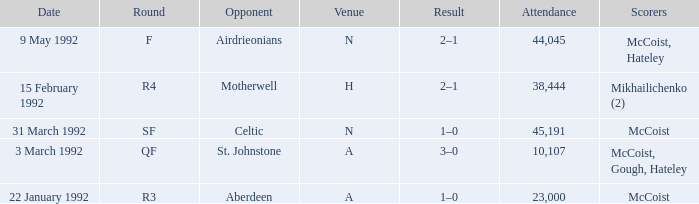Could you parse the entire table? {'header': ['Date', 'Round', 'Opponent', 'Venue', 'Result', 'Attendance', 'Scorers'], 'rows': [['9 May 1992', 'F', 'Airdrieonians', 'N', '2–1', '44,045', 'McCoist, Hateley'], ['15 February 1992', 'R4', 'Motherwell', 'H', '2–1', '38,444', 'Mikhailichenko (2)'], ['31 March 1992', 'SF', 'Celtic', 'N', '1–0', '45,191', 'McCoist'], ['3 March 1992', 'QF', 'St. Johnstone', 'A', '3–0', '10,107', 'McCoist, Gough, Hateley'], ['22 January 1992', 'R3', 'Aberdeen', 'A', '1–0', '23,000', 'McCoist']]} What is the result with an attendance larger than 10,107 and Celtic as the opponent? 1–0. 